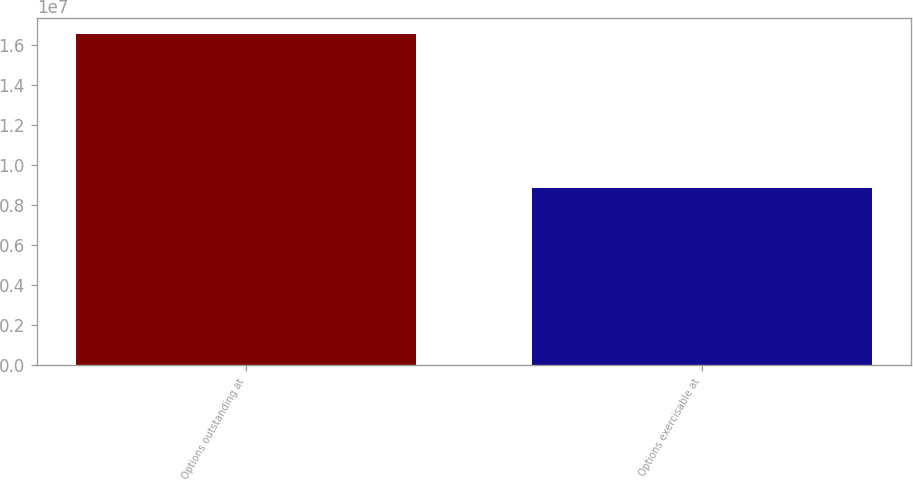Convert chart. <chart><loc_0><loc_0><loc_500><loc_500><bar_chart><fcel>Options outstanding at<fcel>Options exercisable at<nl><fcel>1.65559e+07<fcel>8.83739e+06<nl></chart> 